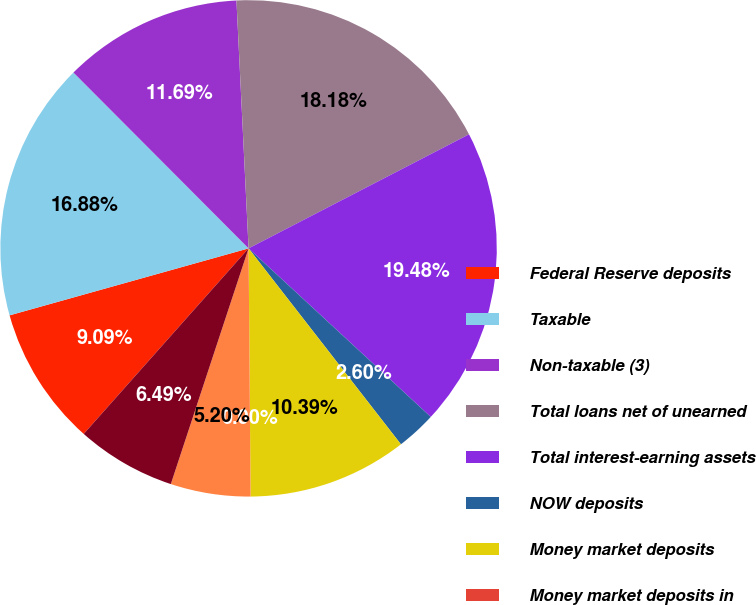Convert chart to OTSL. <chart><loc_0><loc_0><loc_500><loc_500><pie_chart><fcel>Federal Reserve deposits<fcel>Taxable<fcel>Non-taxable (3)<fcel>Total loans net of unearned<fcel>Total interest-earning assets<fcel>NOW deposits<fcel>Money market deposits<fcel>Money market deposits in<fcel>Time deposits<fcel>Sweep deposits in foreign<nl><fcel>9.09%<fcel>16.88%<fcel>11.69%<fcel>18.18%<fcel>19.48%<fcel>2.6%<fcel>10.39%<fcel>0.0%<fcel>5.2%<fcel>6.49%<nl></chart> 